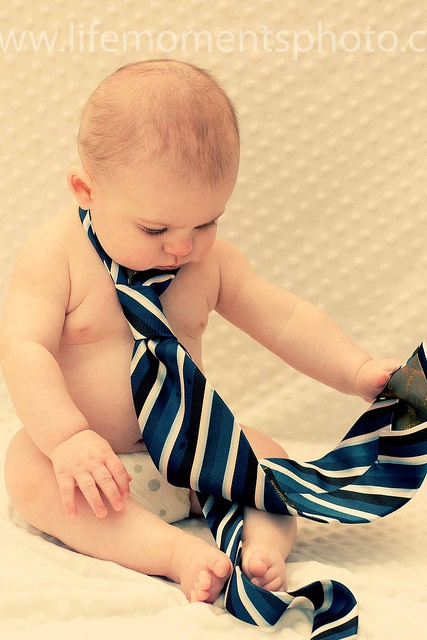Describe the objects in this image and their specific colors. I can see people in tan and black tones and tie in tan, black, darkblue, and blue tones in this image. 